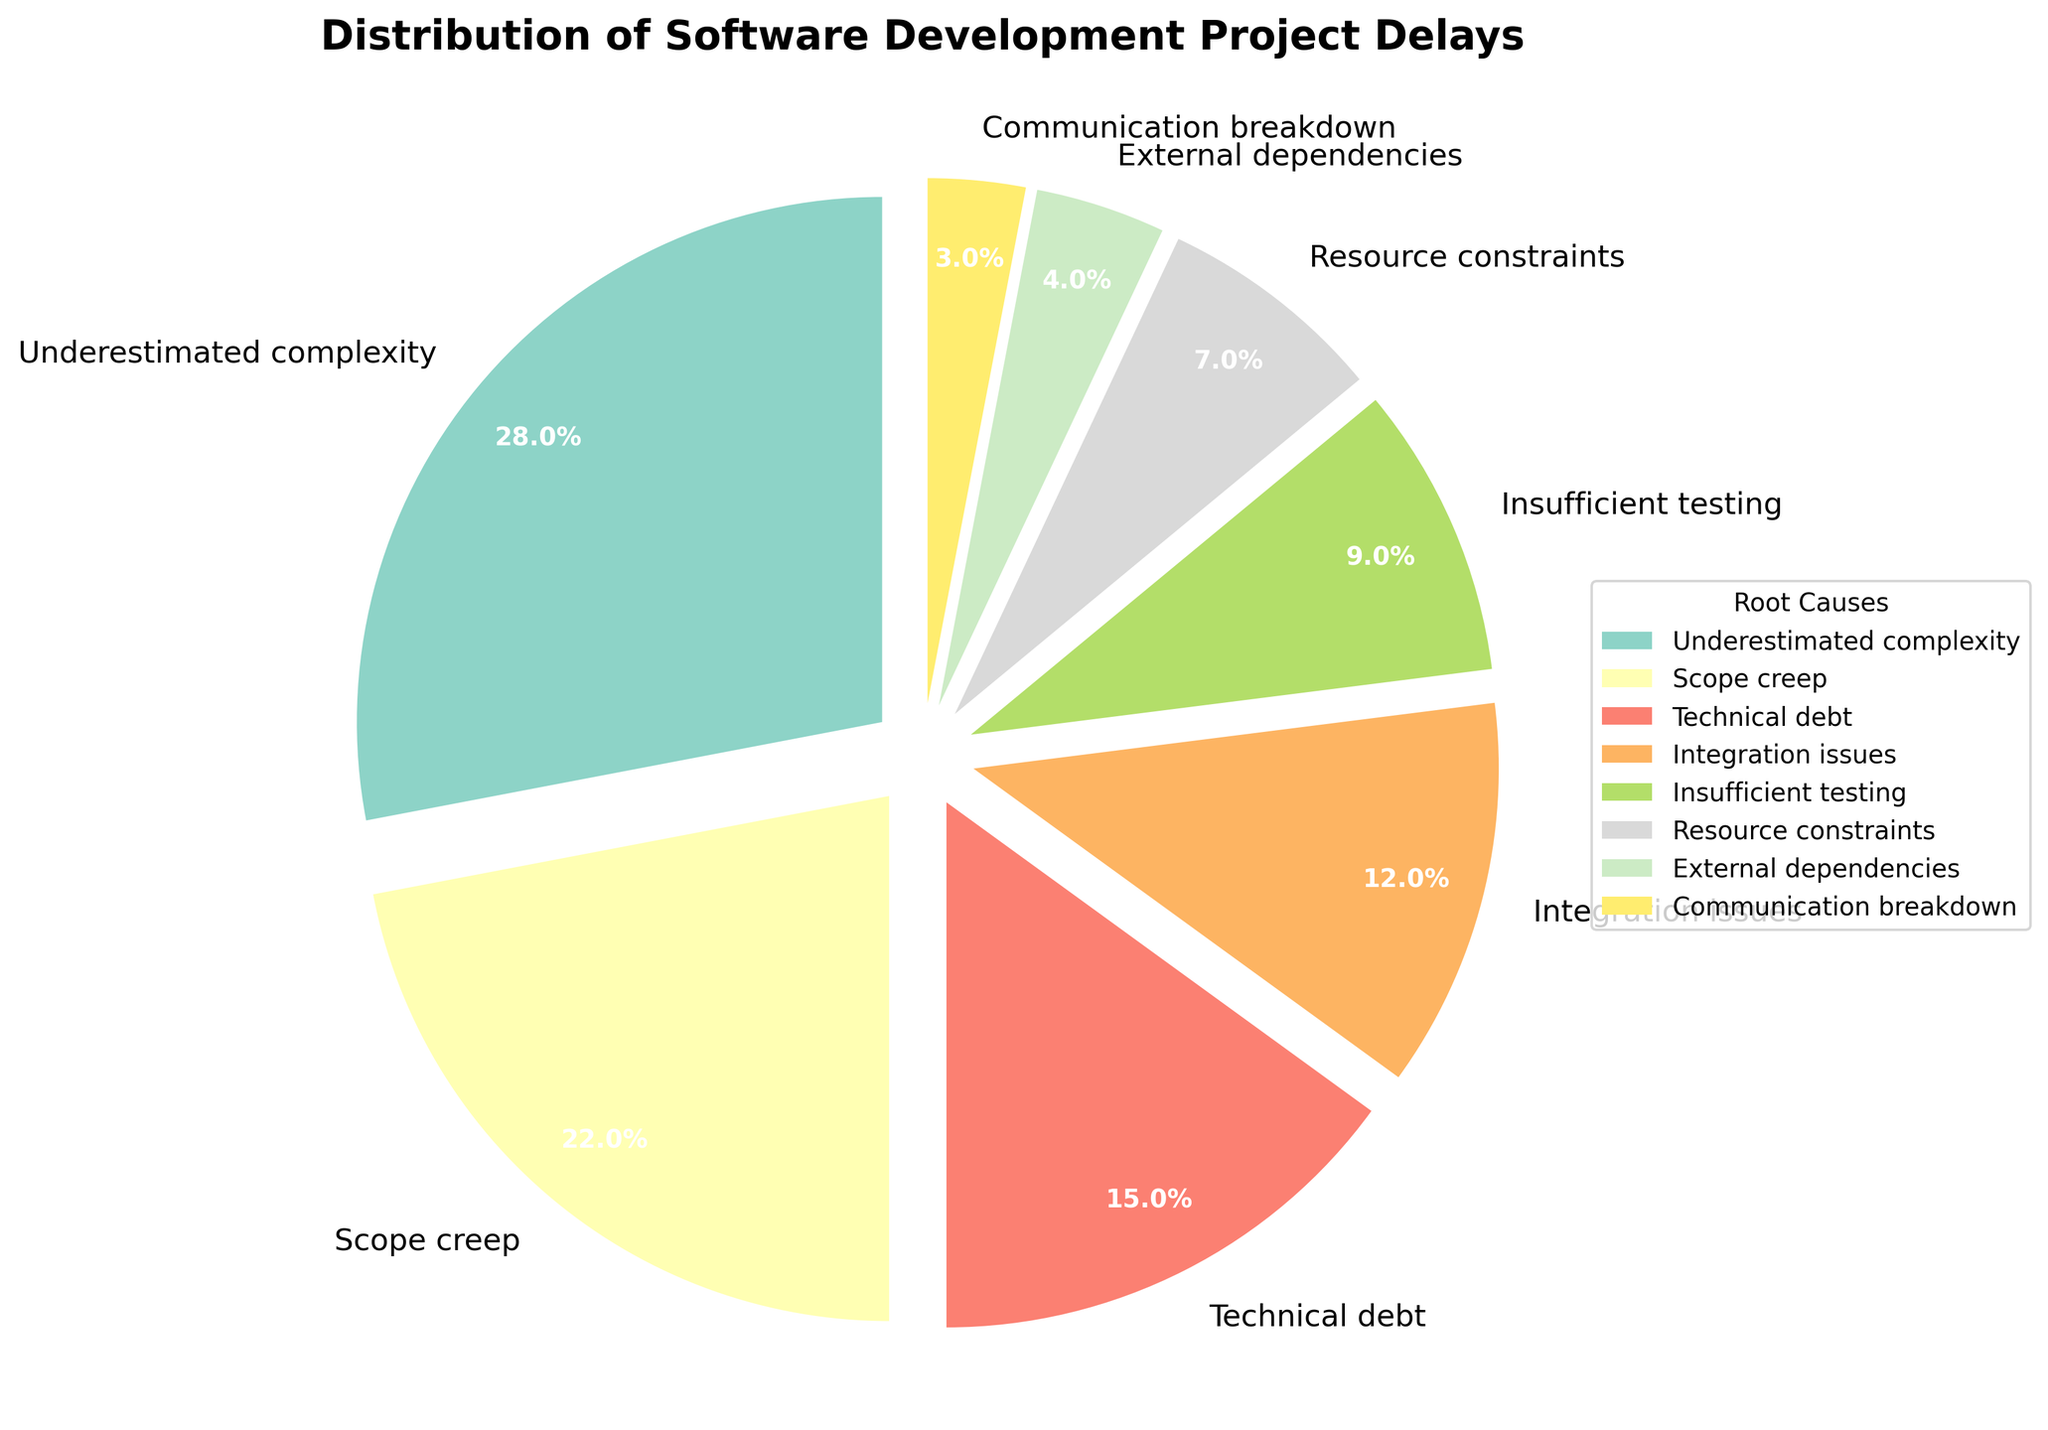Which root cause has the highest percentage? The figure shows the percentage of each root cause for project delays. Underestimated complexity has the highest percentage slice.
Answer: Underestimated complexity Which two causes together account for more than half of the delays? The figure shows each cause and its associated percentage. Adding percentages for "Underestimated complexity" (28%) and "Scope creep" (22%) gives 50%, which is more than half.
Answer: Underestimated complexity and Scope creep How does the percentage of technical debt compare to insufficient testing? The percentages for technical debt and insufficient testing are shown in the figure. Technical debt has 15%, and insufficient testing has 9%, so technical debt is greater.
Answer: Technical debt is greater What's the difference in percentage between integration issues and resource constraints? Integration issues have a percentage of 12%, while resource constraints have 7%. Subtracting 7 from 12 gives a difference of 5%.
Answer: 5% What percentage of delays are caused by external dependencies or communication breakdown combined? External dependencies account for 4% and communication breakdown accounts for 3%. Adding 4% and 3% gives a total of 7%.
Answer: 7% Is the segment representing scope creep larger or smaller than the segment representing integration issues? The figure shows scope creep at 22% and integration issues at 12%. 22% is larger than 12%, so the segment for scope creep is larger.
Answer: Scope creep is larger What percentage does the second most significant cause contribute to delays? The second largest slice after underestimated complexity is scope creep, which has a percentage of 22%.
Answer: 22% How many causes together contribute to less than a quarter (25%) of the delays? Adding the smallest percentages: Communication breakdown (3%), External dependencies (4%), and Resource constraints (7%), Insufficient testing (9%), these sum up to 23%, which is less than 25%. So, four causes together.
Answer: 4 causes Do integration issues represent a higher percentage than technical debt? The figure shows technical debt at 15% and integration issues at 12%. Since 15% is greater than 12%, integration issues have a lower percentage.
Answer: No What is the combined percentage of the two least significant causes? The two smallest percentages are for communication breakdown (3%) and external dependencies (4%). Adding 3% and 4% gives a total of 7%.
Answer: 7% 